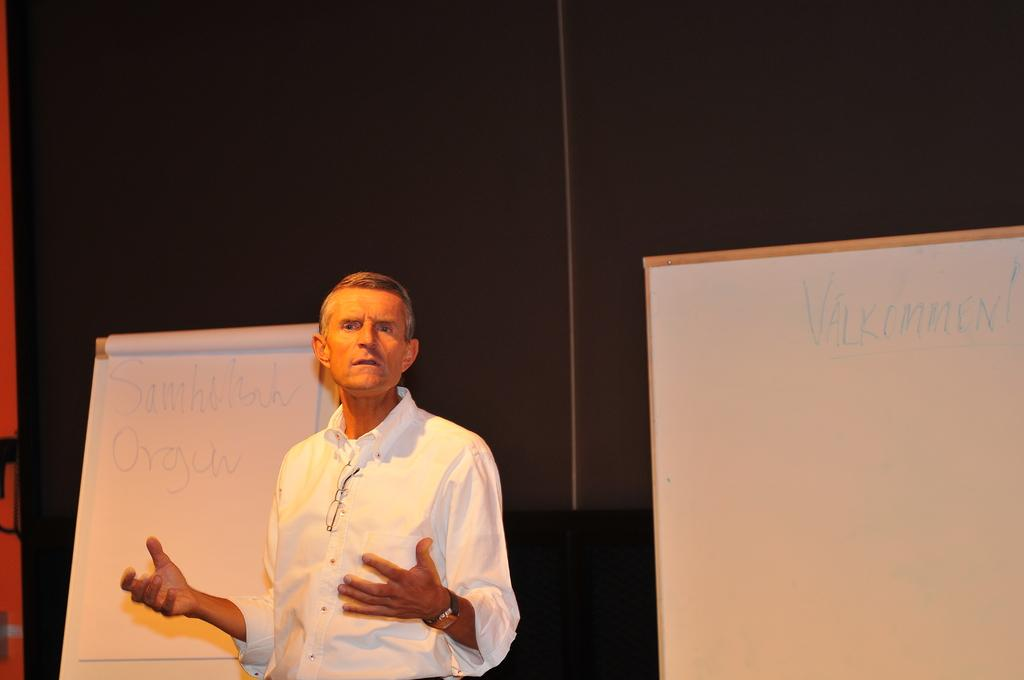Who is present in the image? There is a man in the image. What is the man wearing? The man is wearing a white shirt. What is the man doing in the image? The man is explaining something. What can be seen in the background of the image? There are whiteboards and papers in the background of the image. What is the color of the background in the image? The background of the image is black. What type of honey is being used to set off the alarm in the image? There is no honey or alarm present in the image. 